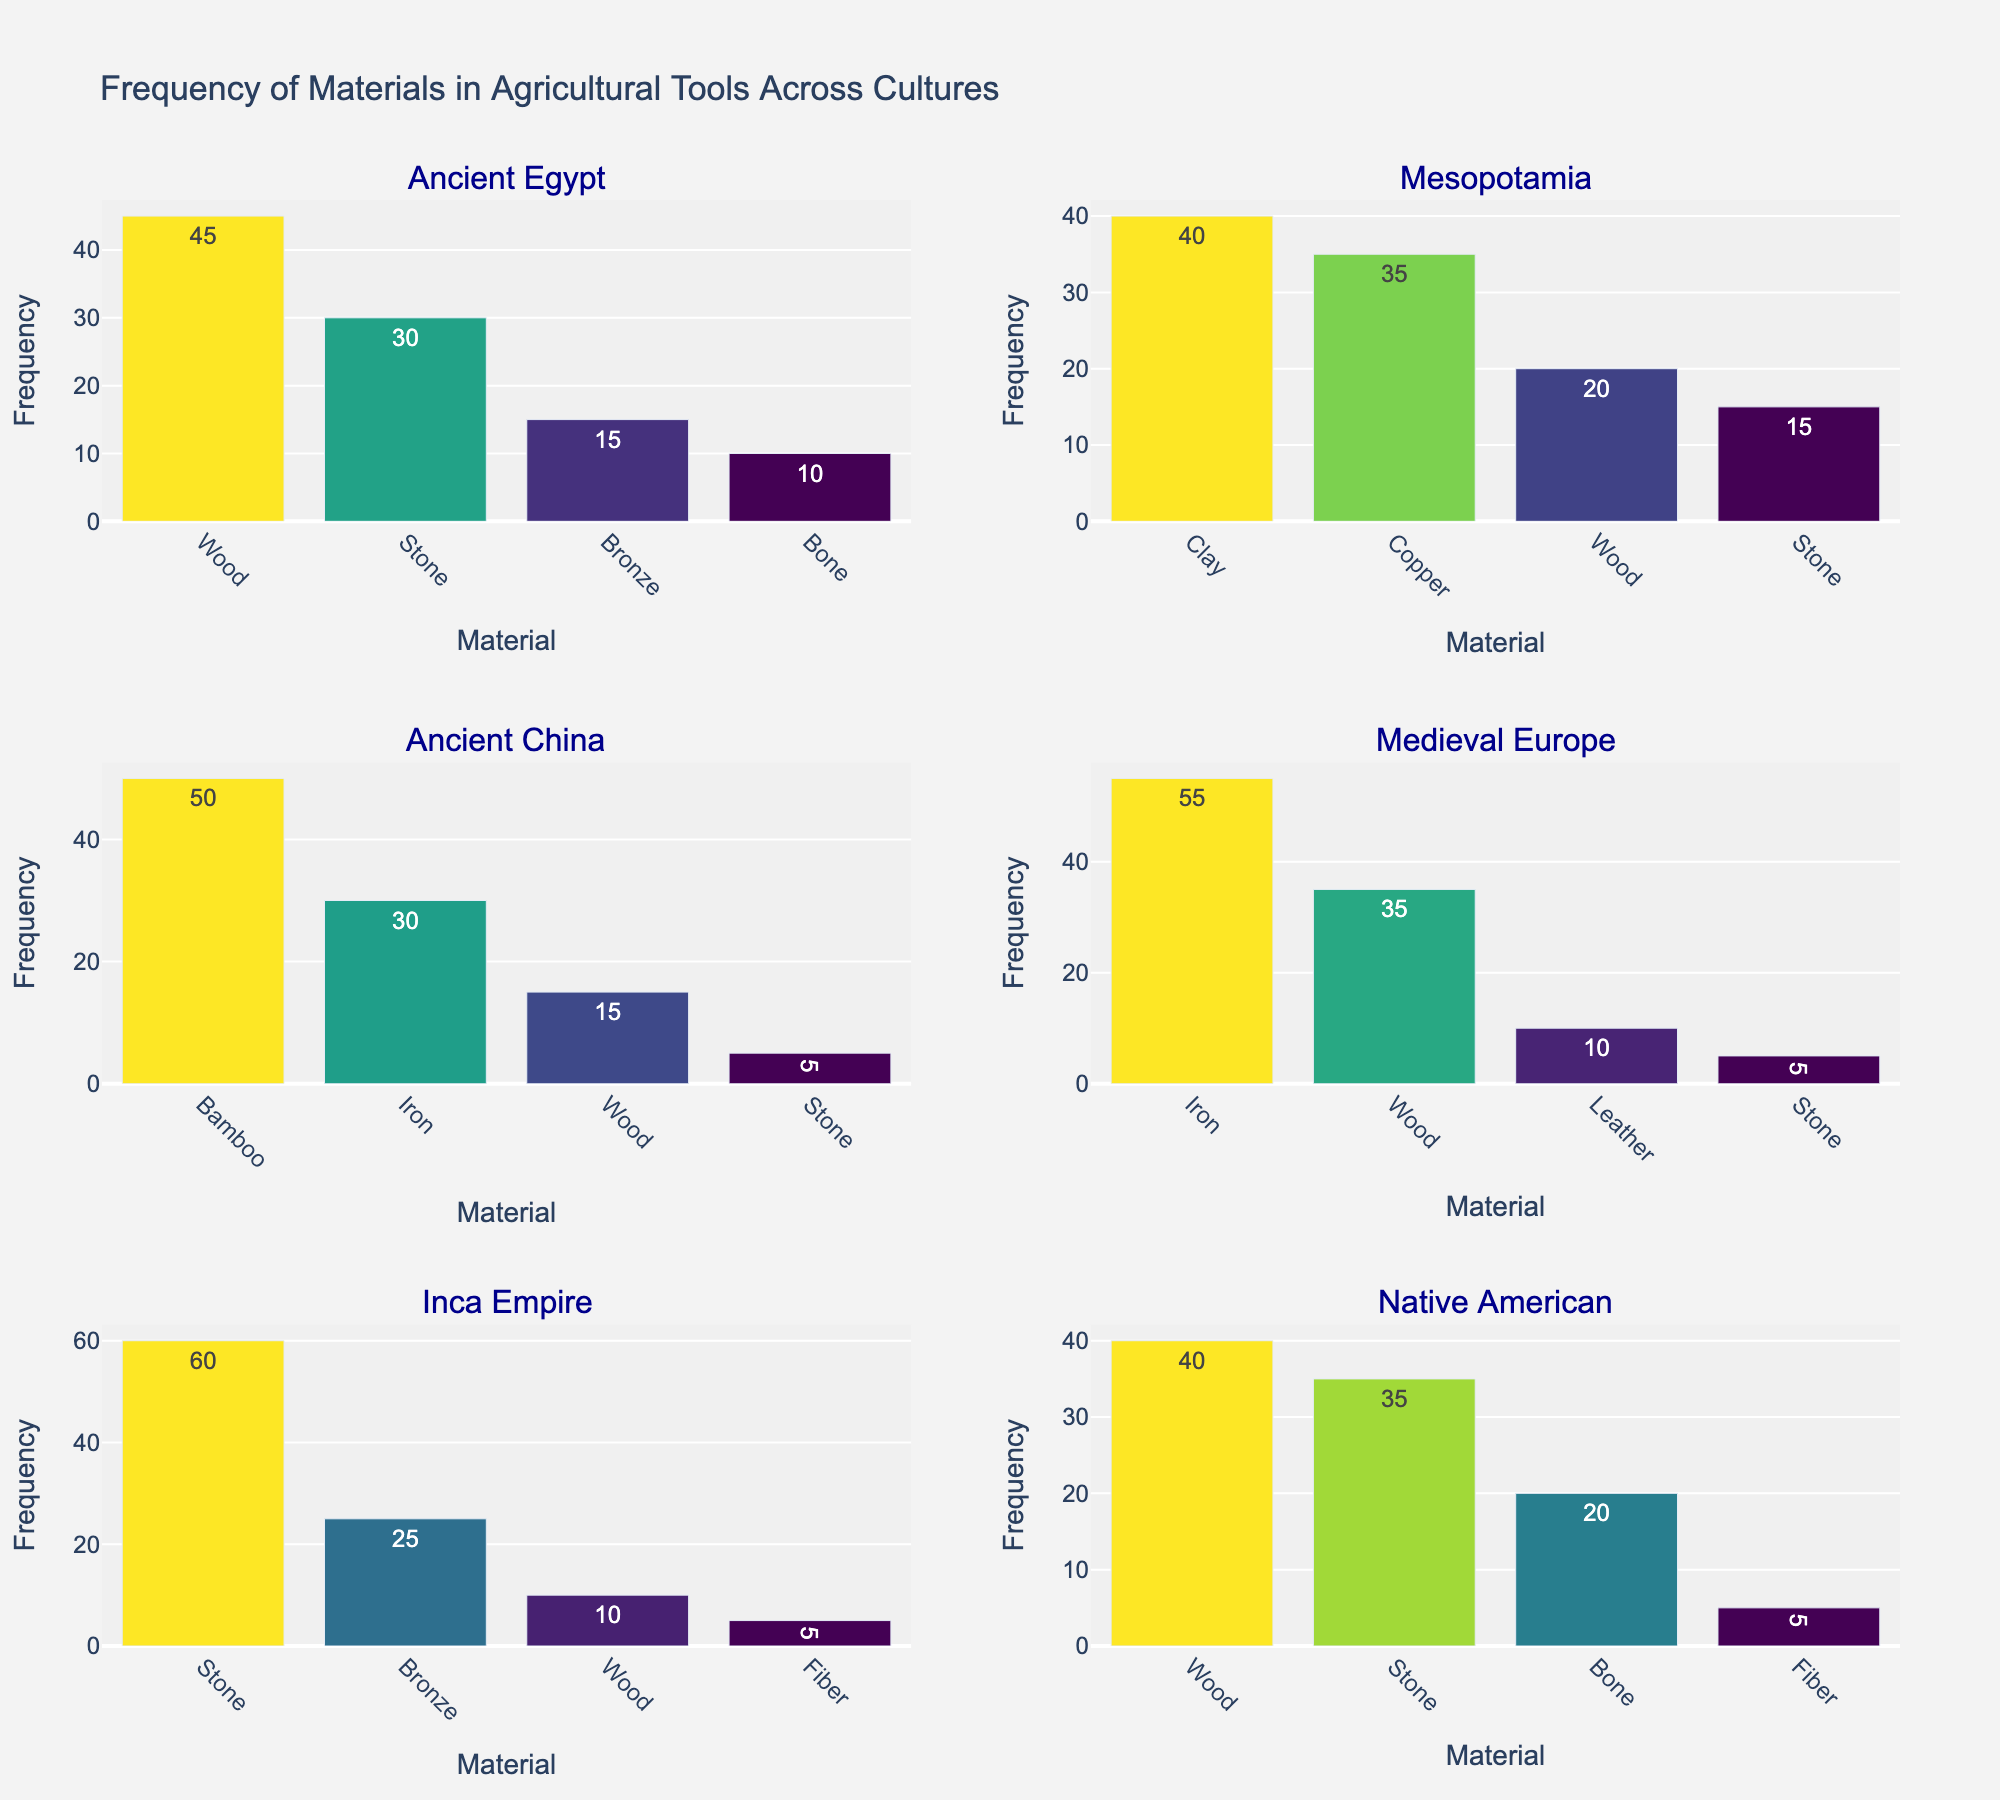What is the most frequently used material in Ancient Egypt agricultural tools? In the subplot for Ancient Egypt, the tallest bar represents the material with the highest frequency, which is Wood.
Answer: Wood Which culture used stone as the most frequent material? In the subplots, the tallest bar for Inca Empire represents Stone with a frequency of 60, indicating it is the most frequent material in that culture.
Answer: Inca Empire How does the use of bronze compare between Ancient Egypt and Inca Empire? In the Ancient Egypt subplot, the height of the bar for Bronze is 15, whereas in the Inca Empire subplot, the height of the bar for Bronze is 25. This shows that the Inca Empire used Bronze more frequently than Ancient Egypt.
Answer: Inca Empire used it more Which two cultures had the highest frequency for any single material and what were the materials? Ancient China and the Inca Empire had the highest frequencies. Ancient China had a Bamboo frequency of 50, and the Inca Empire had a Stone frequency of 60.
Answer: Bamboo in Ancient China and Stone in Inca Empire What is the average frequency of wood usage across all cultures? Summing the frequencies of Wood from all subplots gives 45 (Ancient Egypt) + 20 (Mesopotamia) + 15 (Ancient China) + 35 (Medieval Europe) + 10 (Inca Empire) + 40 (Native American) = 165. Since there are 6 cultures, the average is 165 / 6 = 27.5.
Answer: 27.5 Which culture had the most diverse set of materials used in their agricultural tools? The number of different materials can be counted based on the number of bars in each subplot. Ancient Egypt, Mesopotamia, Ancient China, and Medieval Europe each have 4; Inca Empire and Native American also have 4. Therefore, all these cultures had an equally diverse set with 4 different materials.
Answer: Ancient Egypt, Mesopotamia, Ancient China, Medieval Europe, Inca Empire, Native American (all tied) In which culture was the frequency of fiber usage the highest, and what was the frequency? In the subplots, Fiber is present in the Inca Empire and Native American cultures. Inca Empire shows a bar with a frequency of 5, and Native American also shows a bar with a frequency of 5. Thus, the highest frequency of fiber usage is 5 in both these cultures.
Answer: Inca Empire and Native American with 5 each How does the use of materials in Medieval Europe compare with the use of the same materials in Ancient China? In Medieval Europe and Ancient China, the common materials are Iron, Wood, and Stone. For Iron, Medieval Europe used it 55 times compared to Ancient China's 30 times. For Wood, Medieval Europe used it 35 times compared to Ancient China's 15 times. For Stone, Medieval Europe used it 5 times compared to Ancient China's 5 times.
Answer: Medieval Europe used more Iron and Wood and the same amount of Stone Which culture predominantly used iron in their agricultural tools? The subplot for Medieval Europe shows the highest frequency for Iron usage at 55, indicating it is the predominant material.
Answer: Medieval Europe What's the total frequency of material usage in Ancient Egypt? Summing the frequencies of all materials in the Ancient Egypt subplot gives 45 (Wood) + 30 (Stone) + 15 (Bronze) + 10 (Bone) = 100.
Answer: 100 